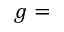Convert formula to latex. <formula><loc_0><loc_0><loc_500><loc_500>g =</formula> 